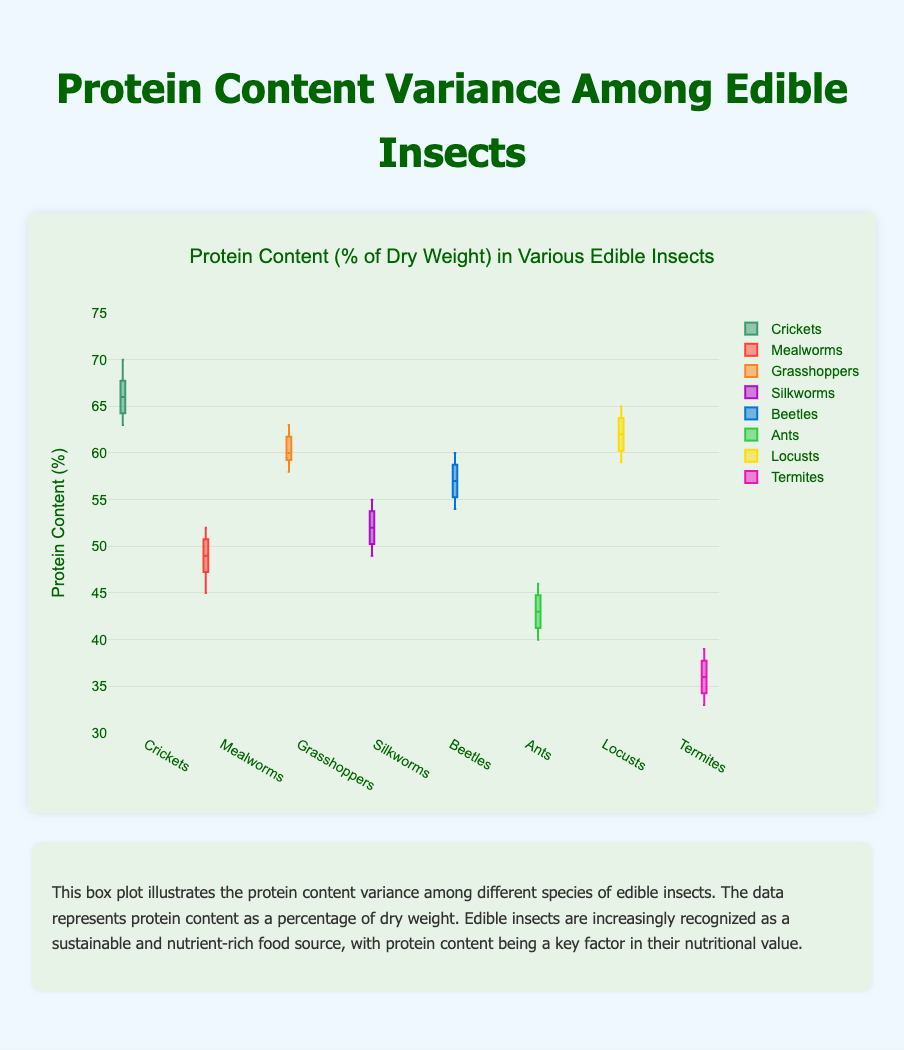Which insect species has the highest median protein content? To find the insect species with the highest median protein content, look for the box plot with the highest line in the middle of the box (the median). For Crickets, the median is around 66.5%, which is the highest among all species.
Answer: Crickets Which species has the most variability in protein content? The variability in protein content is indicated by the length of the box (interquartile range) and the spread of the whiskers. Termites have the widest spread from the smallest to the largest observed value, indicating the highest variability.
Answer: Termites What is the median protein content of Mealworms? To find the median protein content of Mealworms, look at the line inside the box for Mealworms. The median is approximately 49%.
Answer: 49% Which species has the lowest median protein content? The species with the lowest median protein content will have the lowest line inside its box. Termites have the lowest median at around 36%.
Answer: Termites Compare the range of protein content for Ants and Beetles. Which one is greater? The range is calculated by subtracting the smallest observed value from the largest observed value. For Ants, the range is from 40 to 46, which is 6. For Beetles, the range is from 54 to 60, which is 6. Both have the same range.
Answer: Same What is the interquartile range (IQR) for Silkworms' protein content? The interquartile range (IQR) is calculated by subtracting the first quartile (Q1) from the third quartile (Q3). For Silkworms, Q1 is around 50.5 and Q3 is about 53.5, so the IQR is 53.5 - 50.5 = 3.
Answer: 3 Among Crickets and Locusts, which one has a higher upper whisker value? The upper whisker is the highest point in the plot excluding outliers. For Crickets, the upper whisker reaches 70. For Locusts, it also reaches 65. Thus, Crickets have a higher upper whisker.
Answer: Crickets What is the range of protein content for Grasshoppers? The range is the difference between the maximum and minimum values. For Grasshoppers, the maximum is around 63 and the minimum is around 58, making the range 63 - 58 = 5.
Answer: 5 Which insect has the smallest variability in protein content? The smallest variability is indicated by the smallest spread of the data. Crickets have relatively close protein content values (minimal spread), indicating the smallest variability.
Answer: Crickets 